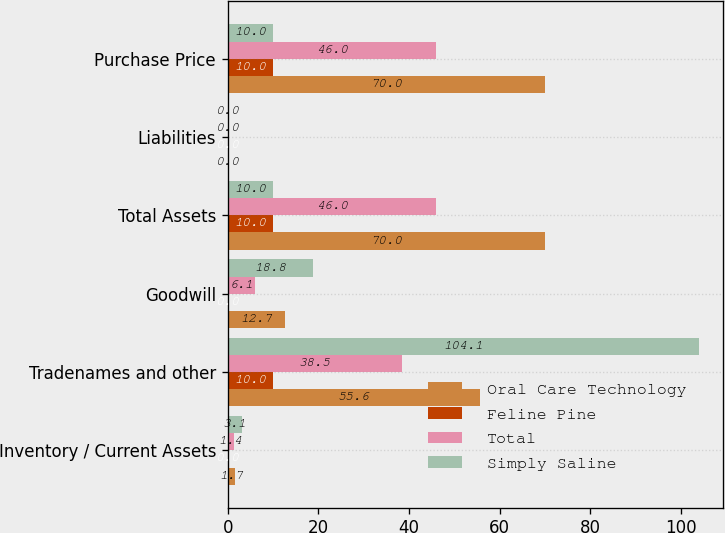<chart> <loc_0><loc_0><loc_500><loc_500><stacked_bar_chart><ecel><fcel>Inventory / Current Assets<fcel>Tradenames and other<fcel>Goodwill<fcel>Total Assets<fcel>Liabilities<fcel>Purchase Price<nl><fcel>Oral Care Technology<fcel>1.7<fcel>55.6<fcel>12.7<fcel>70<fcel>0<fcel>70<nl><fcel>Feline Pine<fcel>0<fcel>10<fcel>0<fcel>10<fcel>0<fcel>10<nl><fcel>Total<fcel>1.4<fcel>38.5<fcel>6.1<fcel>46<fcel>0<fcel>46<nl><fcel>Simply Saline<fcel>3.1<fcel>104.1<fcel>18.8<fcel>10<fcel>0<fcel>10<nl></chart> 